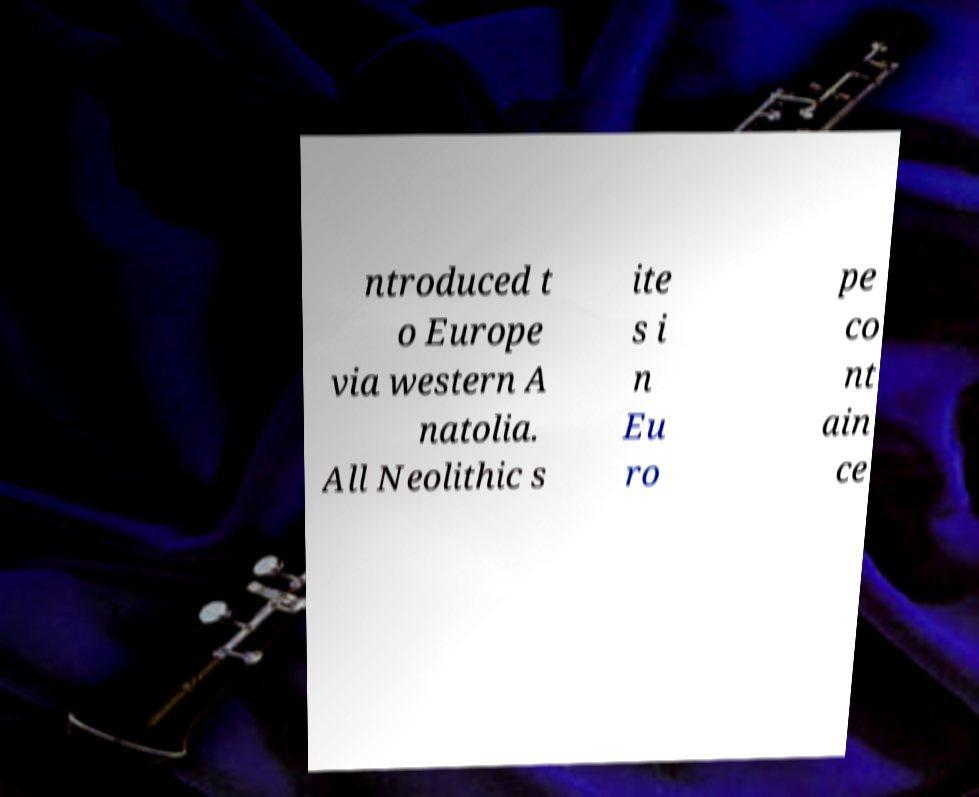I need the written content from this picture converted into text. Can you do that? ntroduced t o Europe via western A natolia. All Neolithic s ite s i n Eu ro pe co nt ain ce 